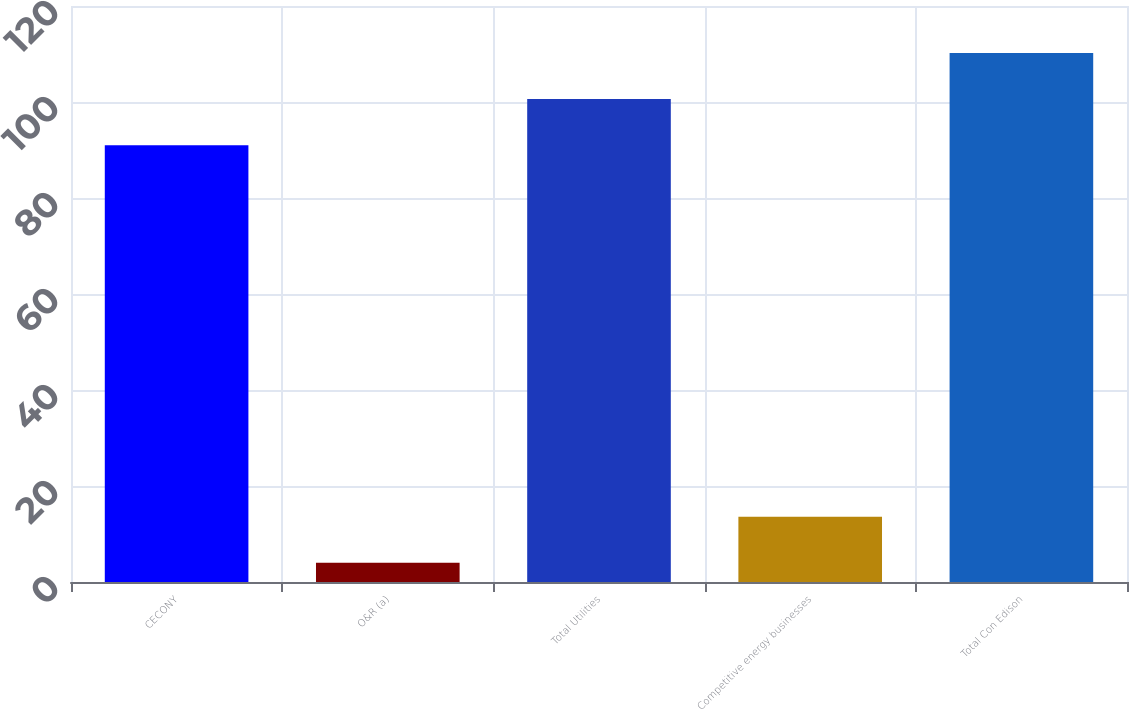Convert chart. <chart><loc_0><loc_0><loc_500><loc_500><bar_chart><fcel>CECONY<fcel>O&R (a)<fcel>Total Utilities<fcel>Competitive energy businesses<fcel>Total Con Edison<nl><fcel>91<fcel>4<fcel>100.6<fcel>13.6<fcel>110.2<nl></chart> 